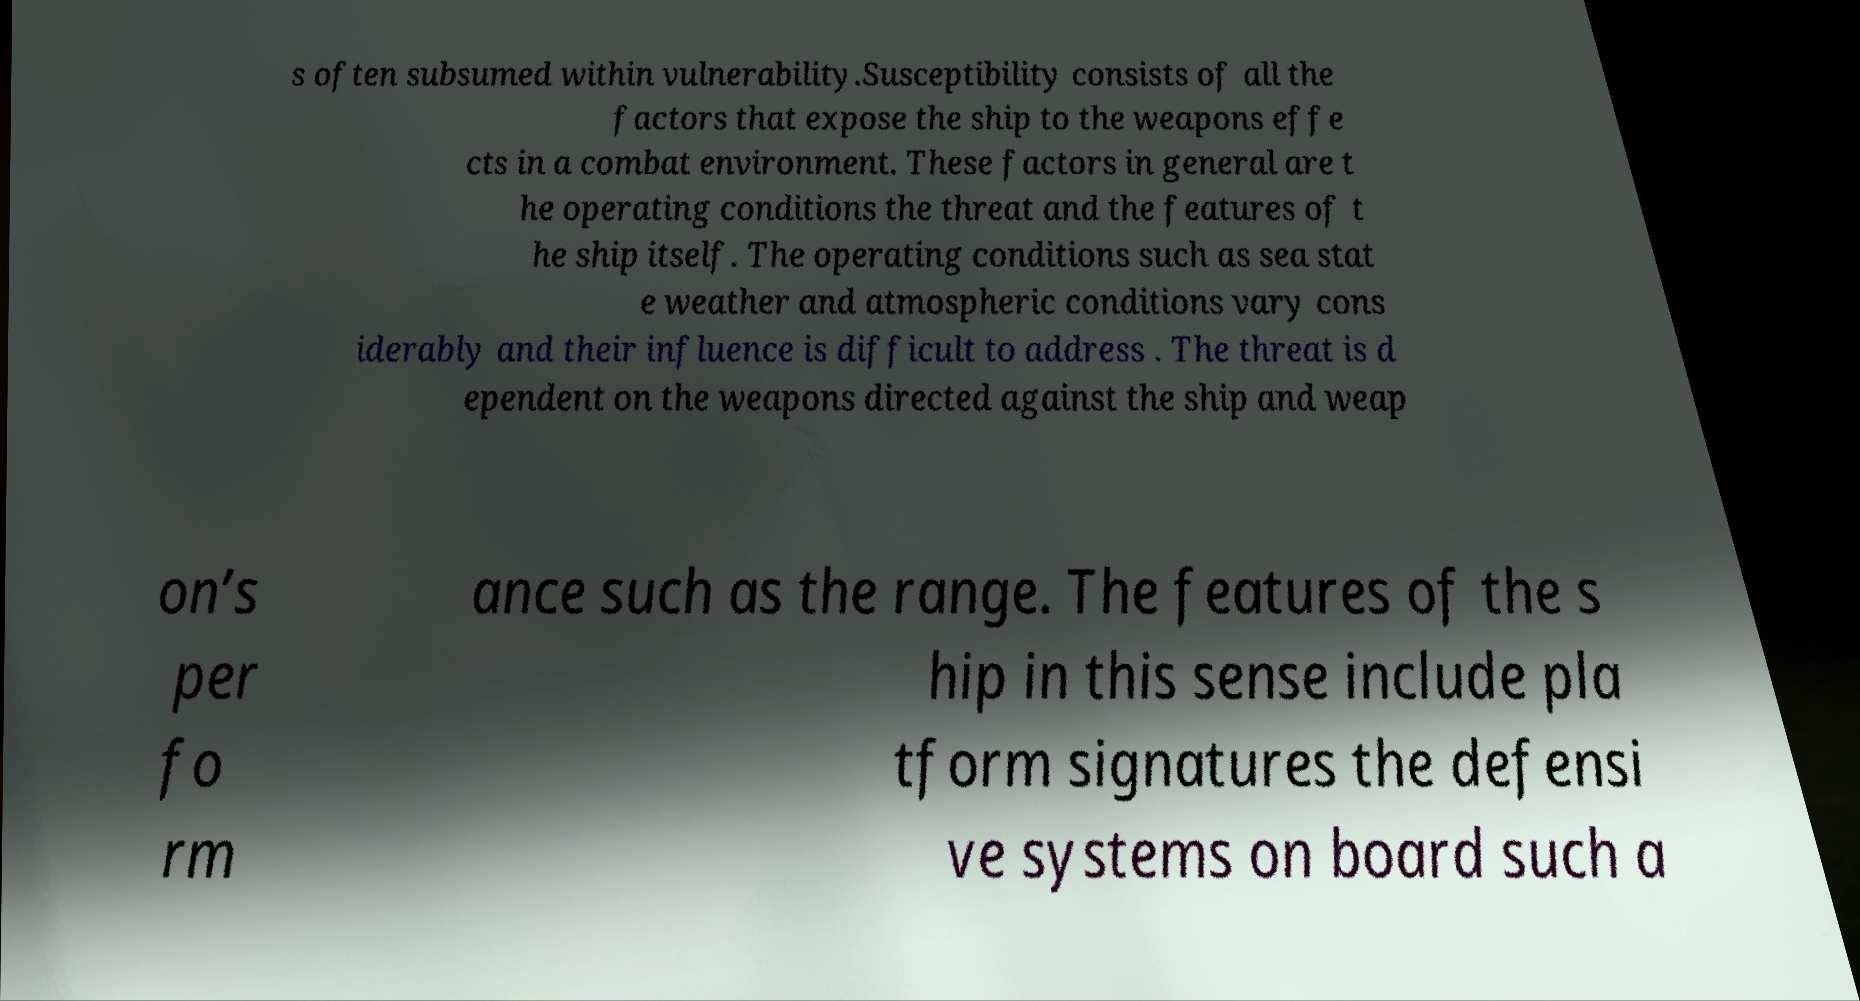I need the written content from this picture converted into text. Can you do that? s often subsumed within vulnerability.Susceptibility consists of all the factors that expose the ship to the weapons effe cts in a combat environment. These factors in general are t he operating conditions the threat and the features of t he ship itself. The operating conditions such as sea stat e weather and atmospheric conditions vary cons iderably and their influence is difficult to address . The threat is d ependent on the weapons directed against the ship and weap on’s per fo rm ance such as the range. The features of the s hip in this sense include pla tform signatures the defensi ve systems on board such a 